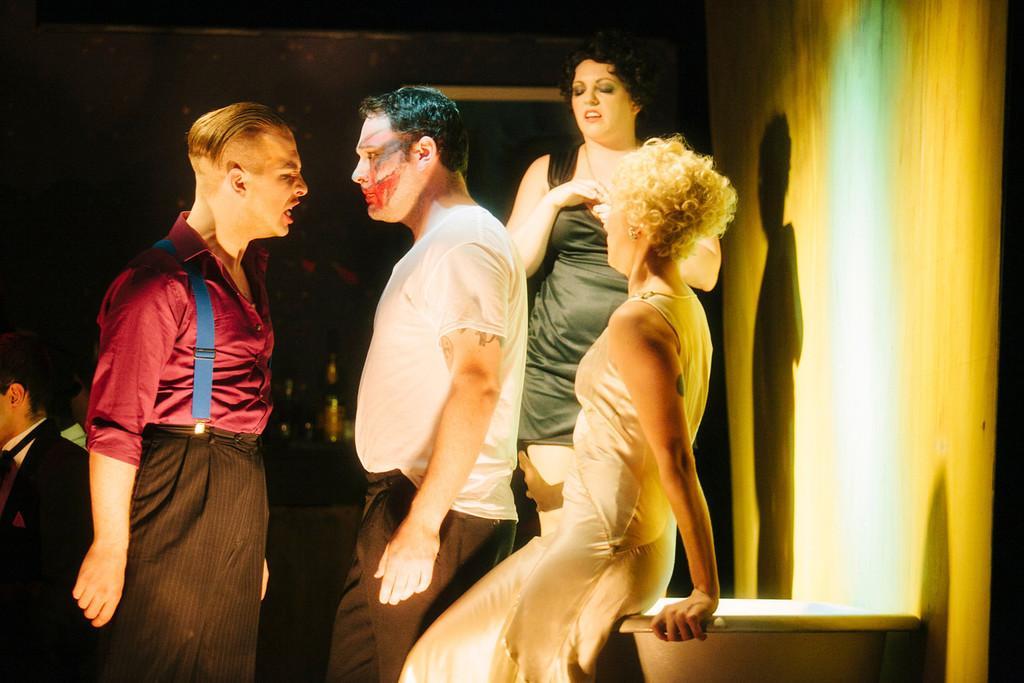Describe this image in one or two sentences. pin this image I can see few people are standing. On the left side there are two men standing and looking at each other. The person who is on the left side it seems like he is shouting. On the right side there is a wall. At the bottom there is an object, beside this there is a woman. The background is in black color. 